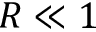Convert formula to latex. <formula><loc_0><loc_0><loc_500><loc_500>R \ll 1</formula> 